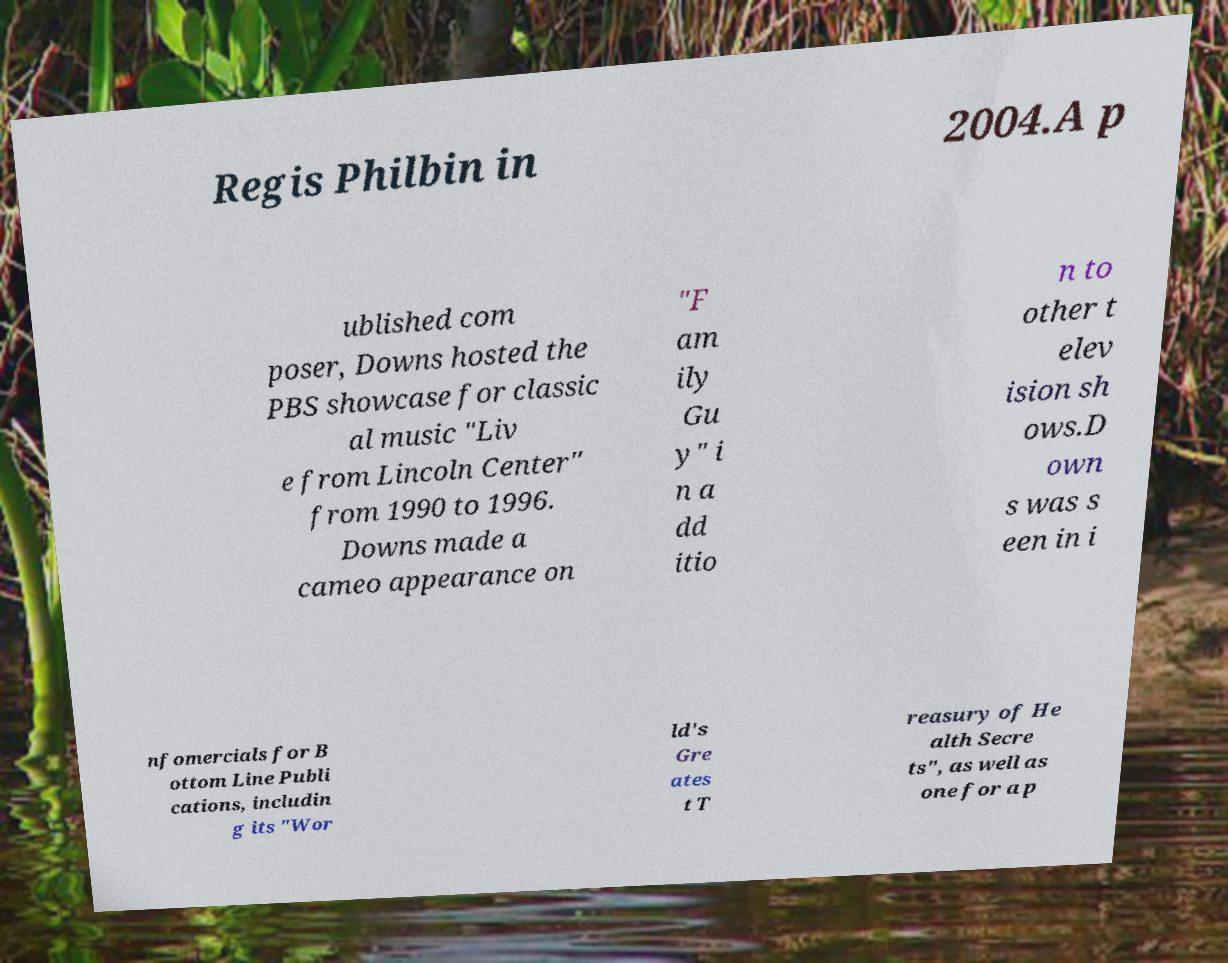Can you accurately transcribe the text from the provided image for me? Regis Philbin in 2004.A p ublished com poser, Downs hosted the PBS showcase for classic al music "Liv e from Lincoln Center" from 1990 to 1996. Downs made a cameo appearance on "F am ily Gu y" i n a dd itio n to other t elev ision sh ows.D own s was s een in i nfomercials for B ottom Line Publi cations, includin g its "Wor ld's Gre ates t T reasury of He alth Secre ts", as well as one for a p 